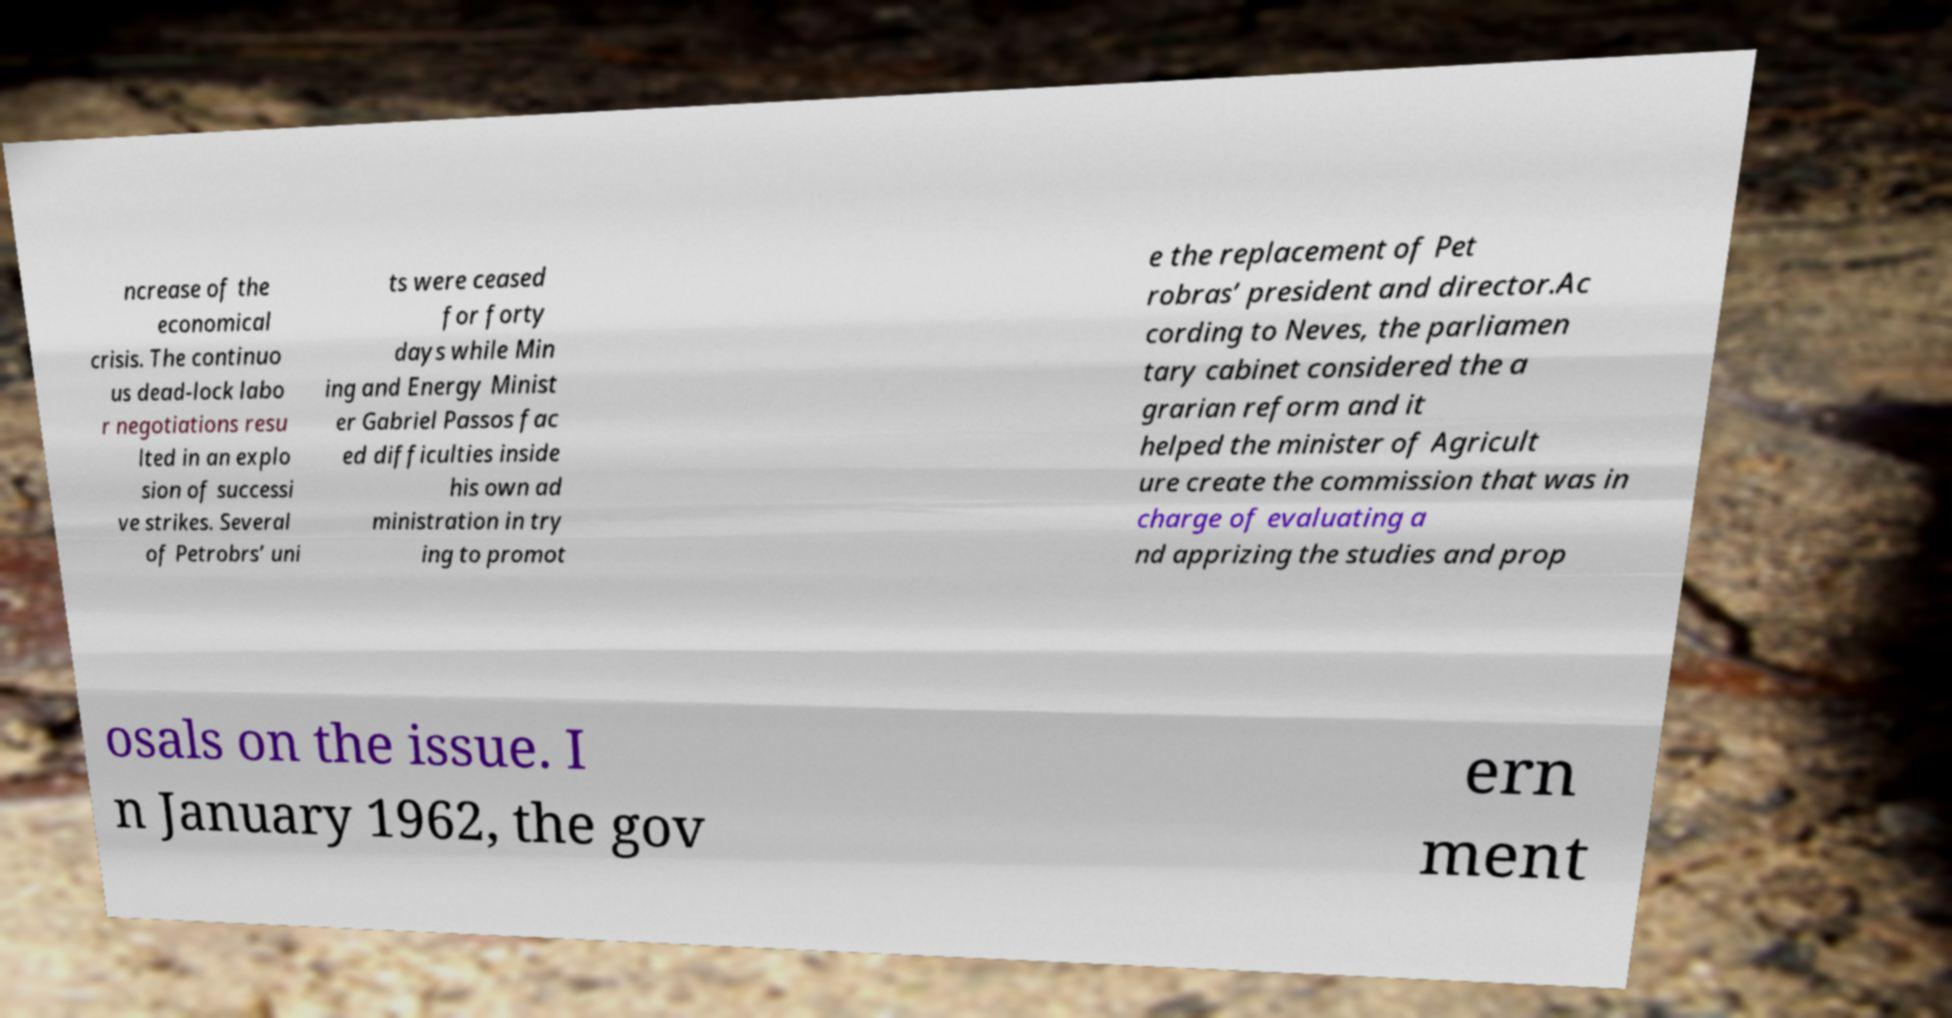There's text embedded in this image that I need extracted. Can you transcribe it verbatim? ncrease of the economical crisis. The continuo us dead-lock labo r negotiations resu lted in an explo sion of successi ve strikes. Several of Petrobrs’ uni ts were ceased for forty days while Min ing and Energy Minist er Gabriel Passos fac ed difficulties inside his own ad ministration in try ing to promot e the replacement of Pet robras’ president and director.Ac cording to Neves, the parliamen tary cabinet considered the a grarian reform and it helped the minister of Agricult ure create the commission that was in charge of evaluating a nd apprizing the studies and prop osals on the issue. I n January 1962, the gov ern ment 